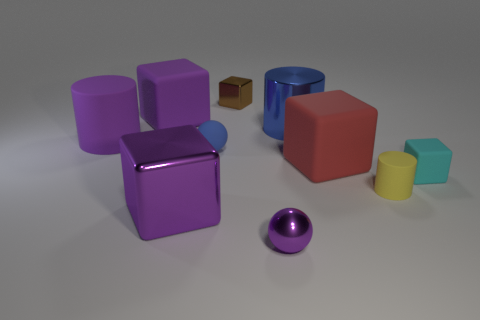There is a large cylinder that is on the right side of the purple sphere; is it the same color as the tiny sphere to the left of the small shiny cube?
Offer a terse response. Yes. Are there fewer blue cylinders that are behind the purple metal sphere than cylinders?
Ensure brevity in your answer.  Yes. There is a large object in front of the small yellow rubber cylinder; is it the same shape as the big rubber object that is to the right of the small brown object?
Offer a terse response. Yes. What number of objects are either small yellow matte cylinders in front of the blue ball or tiny blue rubber spheres?
Your answer should be compact. 2. What is the material of the ball that is the same color as the big metal cube?
Provide a short and direct response. Metal. There is a cylinder in front of the large cube on the right side of the big shiny cylinder; are there any big matte cubes right of it?
Provide a short and direct response. No. Is the number of small blue objects that are right of the small brown metallic cube less than the number of brown metallic objects that are behind the big metal cylinder?
Your answer should be compact. Yes. What is the color of the tiny block that is made of the same material as the big blue thing?
Provide a short and direct response. Brown. There is a large cylinder that is to the right of the matte cylinder left of the small yellow object; what color is it?
Keep it short and to the point. Blue. Is there a rubber cylinder of the same color as the large metal block?
Ensure brevity in your answer.  Yes. 